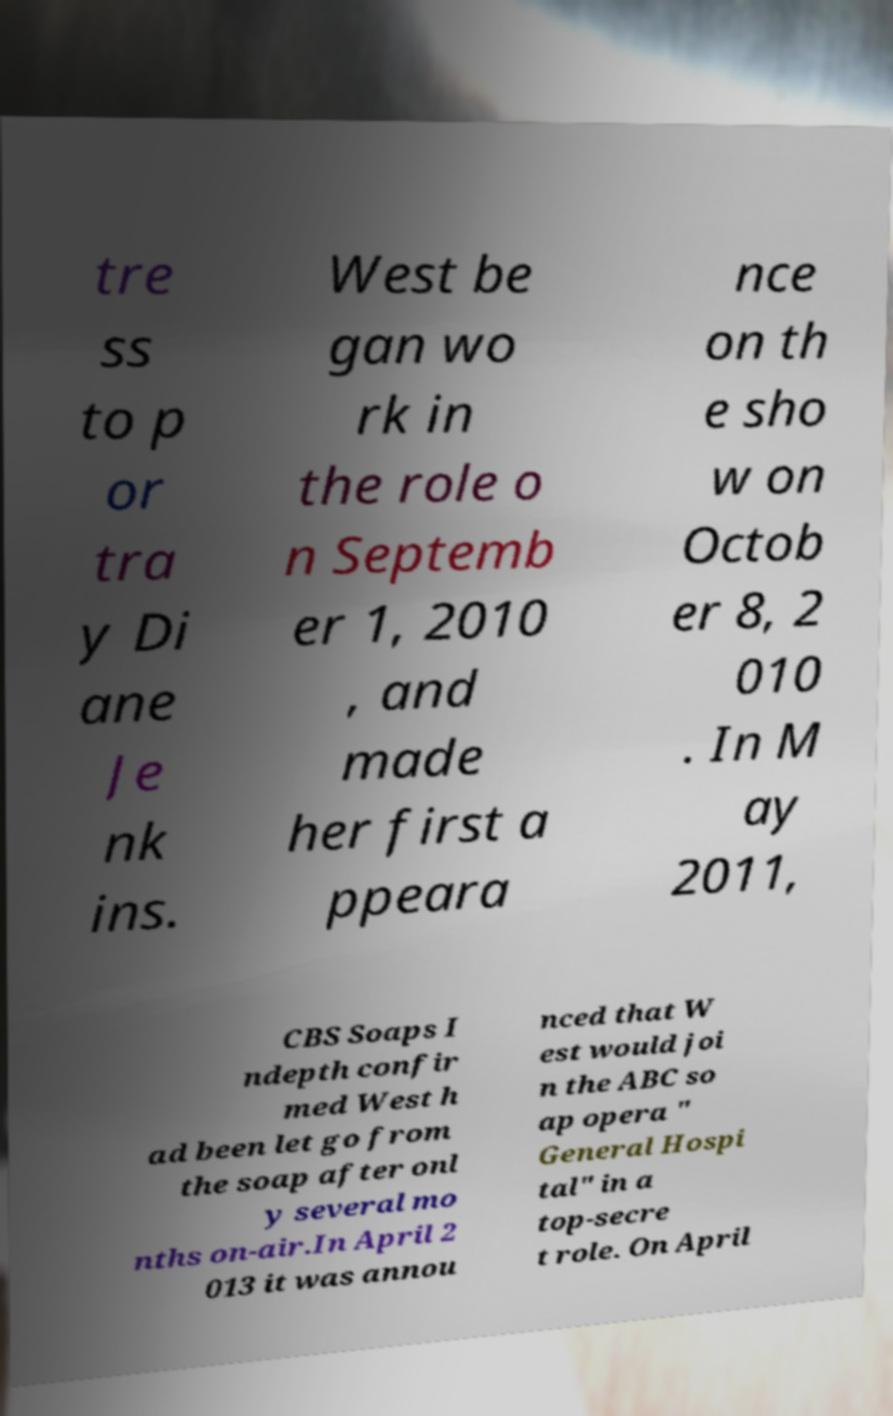What messages or text are displayed in this image? I need them in a readable, typed format. tre ss to p or tra y Di ane Je nk ins. West be gan wo rk in the role o n Septemb er 1, 2010 , and made her first a ppeara nce on th e sho w on Octob er 8, 2 010 . In M ay 2011, CBS Soaps I ndepth confir med West h ad been let go from the soap after onl y several mo nths on-air.In April 2 013 it was annou nced that W est would joi n the ABC so ap opera " General Hospi tal" in a top-secre t role. On April 